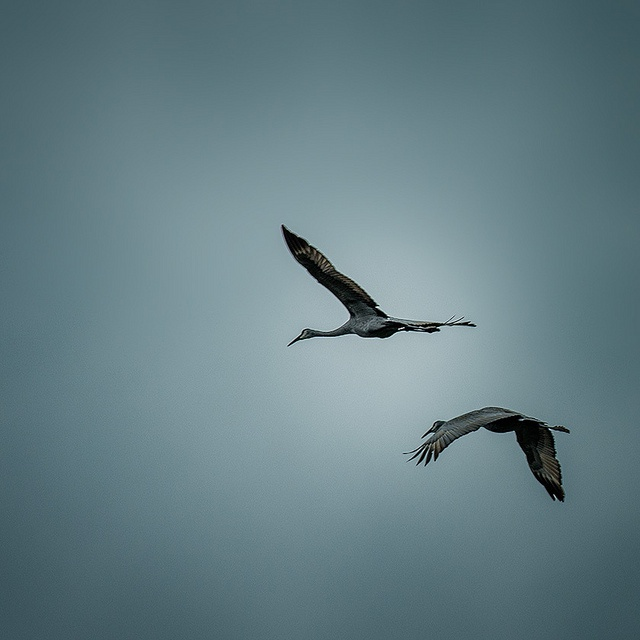Describe the objects in this image and their specific colors. I can see bird in teal, black, gray, and purple tones and bird in teal, black, gray, darkgray, and purple tones in this image. 